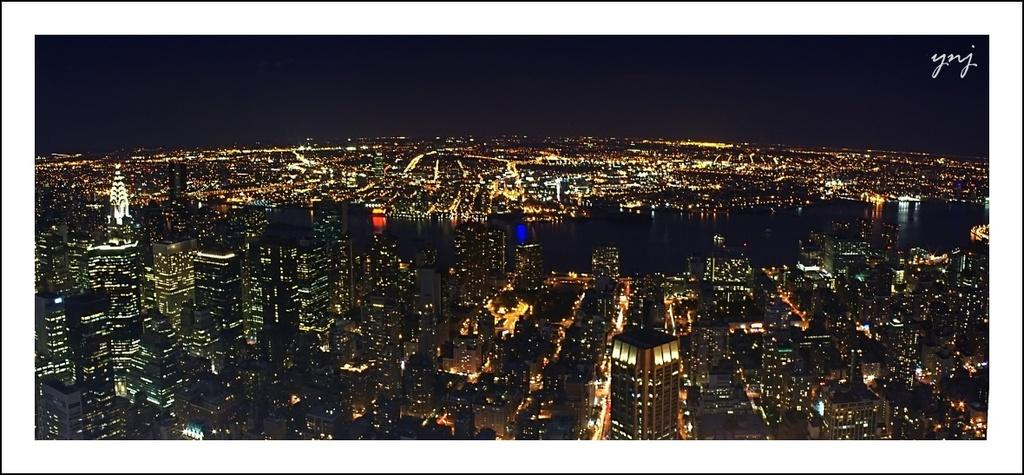What type of structures are present in the image? The image contains buildings. What time of day is depicted in the image? The image is depicted during nighttime. How are the buildings illuminated in the image? The buildings have lights on. What type of airplane can be seen flying over the buildings in the image? There is no airplane visible in the image; it only contains buildings. What shape is the building on the left side of the image? The provided facts do not mention the shape of any building in the image. 